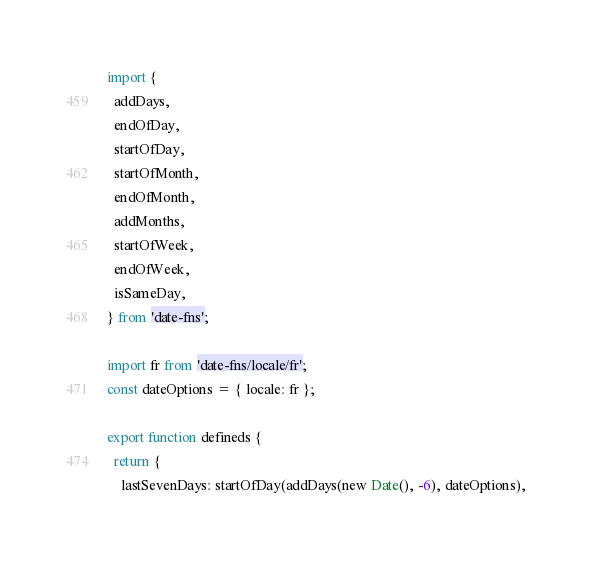<code> <loc_0><loc_0><loc_500><loc_500><_JavaScript_>import {
  addDays,
  endOfDay,
  startOfDay,
  startOfMonth,
  endOfMonth,
  addMonths,
  startOfWeek,
  endOfWeek,
  isSameDay,
} from 'date-fns';

import fr from 'date-fns/locale/fr';
const dateOptions = { locale: fr };

export function defineds {
  return {
    lastSevenDays: startOfDay(addDays(new Date(), -6), dateOptions),</code> 